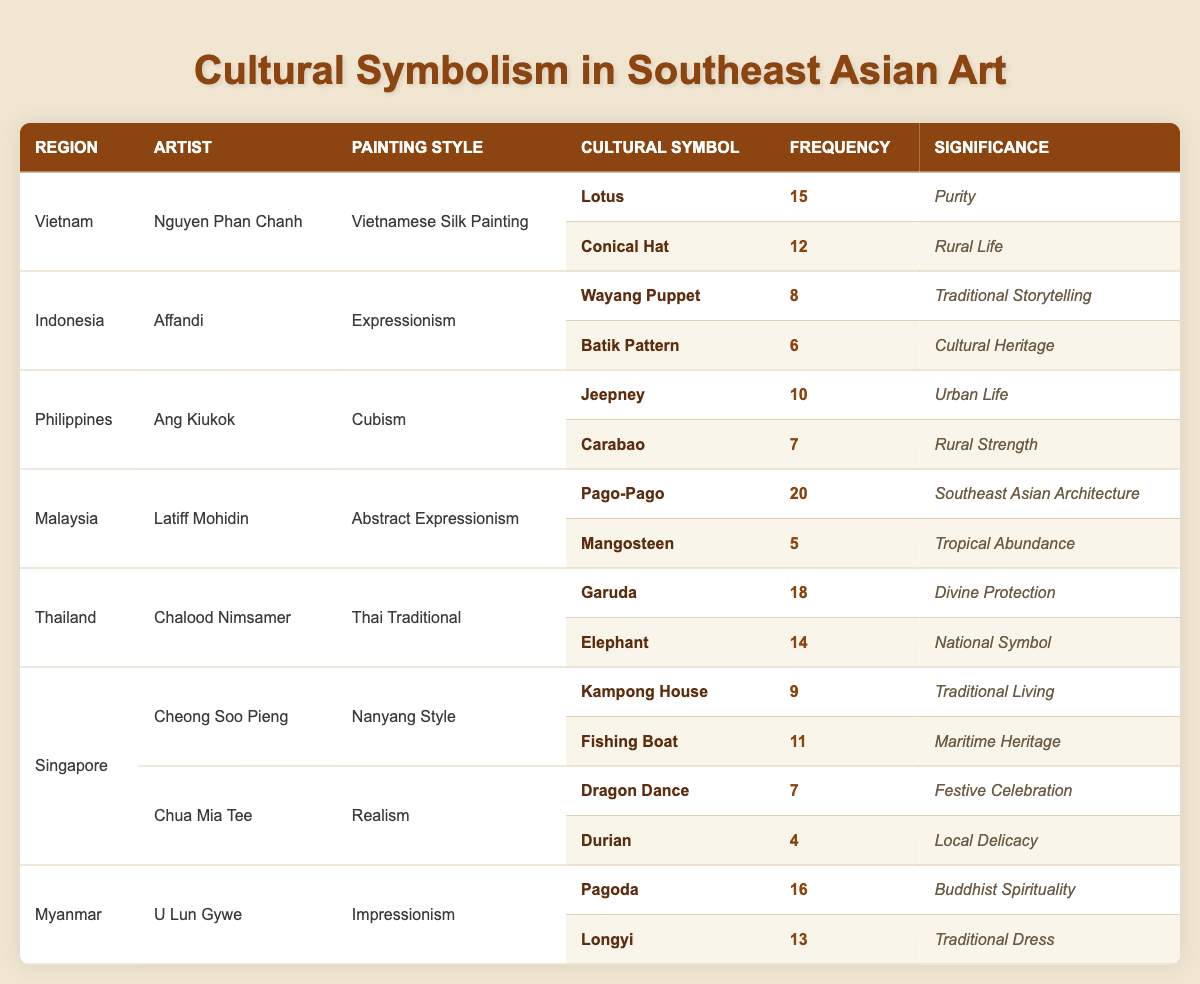What is the most frequently used cultural symbol in Malaysian art? The symbol "Pago-Pago" appears with a frequency of 20 in the table, which is the highest among all cultural symbols listed for Malaysian art.
Answer: Pago-Pago How many cultural symbols did Nguyen Phan Chanh use in his paintings? Nguyen Phan Chanh has used two cultural symbols in his paintings: "Lotus" (15) and "Conical Hat" (12). Hence, the total number of symbols is 2.
Answer: 2 Which artist has depicted the most significant cultural symbol based on frequency? To determine the artist with the most significant cultural symbol, we look for the highest frequency. "Pago-Pago" by Latiff Mohidin has a frequency of 20, which is the highest recorded in the table.
Answer: Latiff Mohidin Are there any artists who depicted more than one cultural symbol? Yes, some artists, such as Nguyen Phan Chanh, Affandi, Ang Kiukok, and others, depicted more than one cultural symbol in their style.
Answer: Yes What is the average frequency of cultural symbols used by artists from Singapore? In Singapore, the frequencies for cultural symbols "Kampong House" (9), "Fishing Boat" (11), "Dragon Dance" (7), and "Durian" (4) are summed up to 31. Dividing by 4 gives an average frequency of 7.75 for cultural symbols used by Singaporean artists.
Answer: 7.75 Which region demonstrated the highest diversity of cultural symbolism based on the number of rows in the table? By counting the rows per region, it is clear that Singapore has four rows in the dataset. This indicates that Singapore has the highest diversity of cultural symbols among all listed regions.
Answer: Singapore What is the significance of the "Elephant" symbol used by Chalood Nimsamer? The significance of the "Elephant" symbol, as noted in the table, is classified as "National Symbol," which indicates its importance in representing Thai culture and identity.
Answer: National Symbol How many cultural symbols appear with a significance related to "Traditional"? In the table, "Conical Hat" and "Traditional Dress" both have significance related to "Traditional." Hence, there are 2 cultural symbols with this significance.
Answer: 2 What is the total frequency of cultural symbols associated with Thai traditional painting style? For the Thai traditional painting style, "Garuda" has a frequency of 18 and "Elephant" has a frequency of 14. So, the total frequency is 18 + 14 = 32.
Answer: 32 